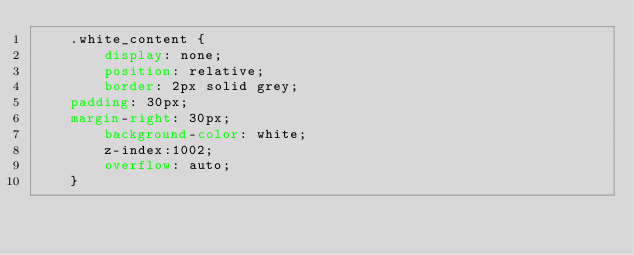Convert code to text. <code><loc_0><loc_0><loc_500><loc_500><_CSS_>    .white_content {
        display: none;
        position: relative;
        border: 2px solid grey;
	padding: 30px;
	margin-right: 30px;
        background-color: white;
        z-index:1002;
        overflow: auto;
    }
</code> 